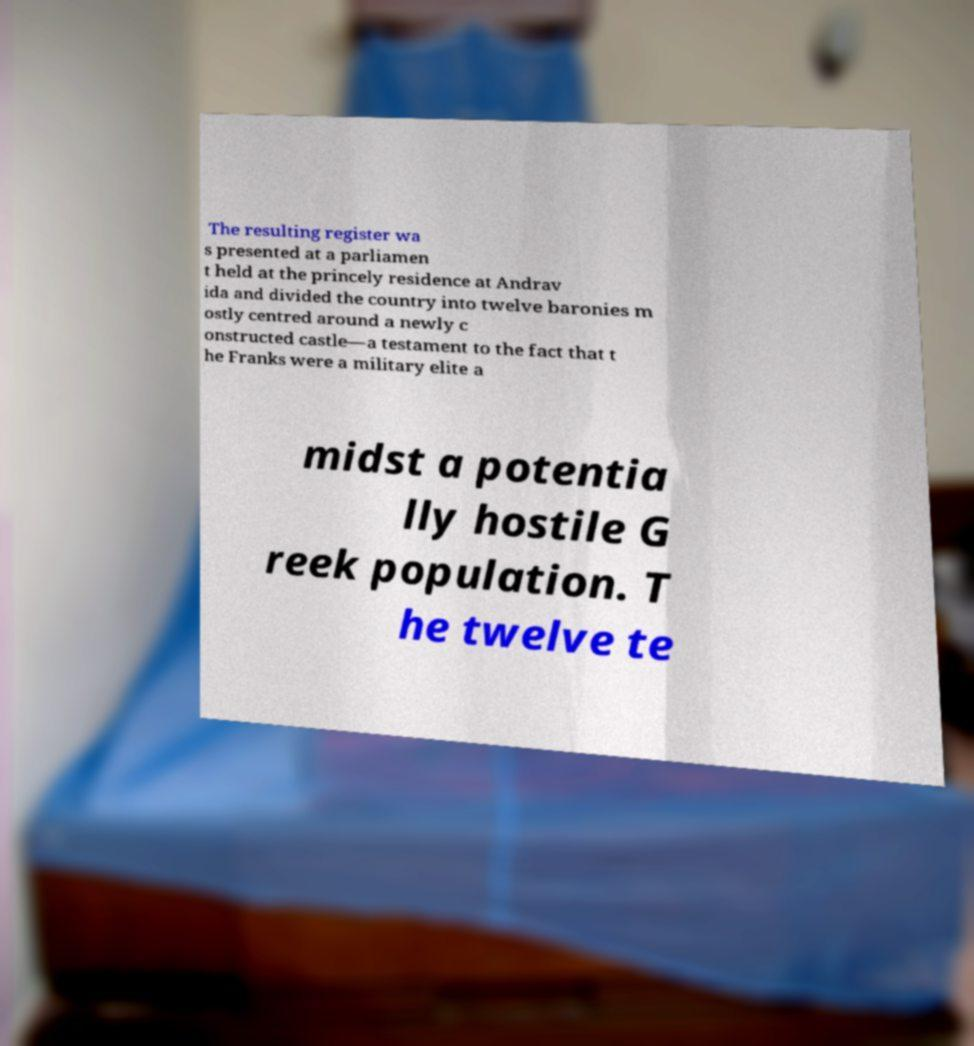Please identify and transcribe the text found in this image. The resulting register wa s presented at a parliamen t held at the princely residence at Andrav ida and divided the country into twelve baronies m ostly centred around a newly c onstructed castle—a testament to the fact that t he Franks were a military elite a midst a potentia lly hostile G reek population. T he twelve te 